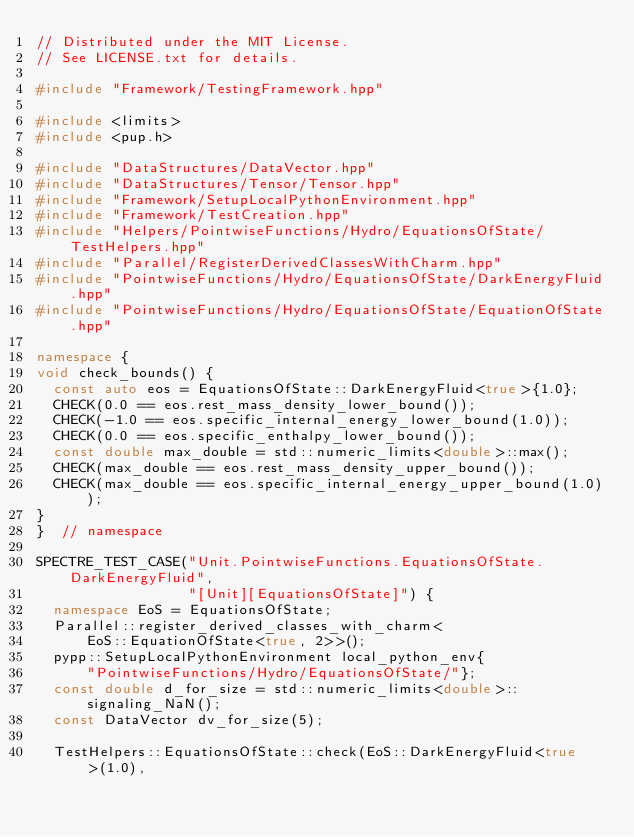<code> <loc_0><loc_0><loc_500><loc_500><_C++_>// Distributed under the MIT License.
// See LICENSE.txt for details.

#include "Framework/TestingFramework.hpp"

#include <limits>
#include <pup.h>

#include "DataStructures/DataVector.hpp"
#include "DataStructures/Tensor/Tensor.hpp"
#include "Framework/SetupLocalPythonEnvironment.hpp"
#include "Framework/TestCreation.hpp"
#include "Helpers/PointwiseFunctions/Hydro/EquationsOfState/TestHelpers.hpp"
#include "Parallel/RegisterDerivedClassesWithCharm.hpp"
#include "PointwiseFunctions/Hydro/EquationsOfState/DarkEnergyFluid.hpp"
#include "PointwiseFunctions/Hydro/EquationsOfState/EquationOfState.hpp"

namespace {
void check_bounds() {
  const auto eos = EquationsOfState::DarkEnergyFluid<true>{1.0};
  CHECK(0.0 == eos.rest_mass_density_lower_bound());
  CHECK(-1.0 == eos.specific_internal_energy_lower_bound(1.0));
  CHECK(0.0 == eos.specific_enthalpy_lower_bound());
  const double max_double = std::numeric_limits<double>::max();
  CHECK(max_double == eos.rest_mass_density_upper_bound());
  CHECK(max_double == eos.specific_internal_energy_upper_bound(1.0));
}
}  // namespace

SPECTRE_TEST_CASE("Unit.PointwiseFunctions.EquationsOfState.DarkEnergyFluid",
                  "[Unit][EquationsOfState]") {
  namespace EoS = EquationsOfState;
  Parallel::register_derived_classes_with_charm<
      EoS::EquationOfState<true, 2>>();
  pypp::SetupLocalPythonEnvironment local_python_env{
      "PointwiseFunctions/Hydro/EquationsOfState/"};
  const double d_for_size = std::numeric_limits<double>::signaling_NaN();
  const DataVector dv_for_size(5);

  TestHelpers::EquationsOfState::check(EoS::DarkEnergyFluid<true>(1.0),</code> 